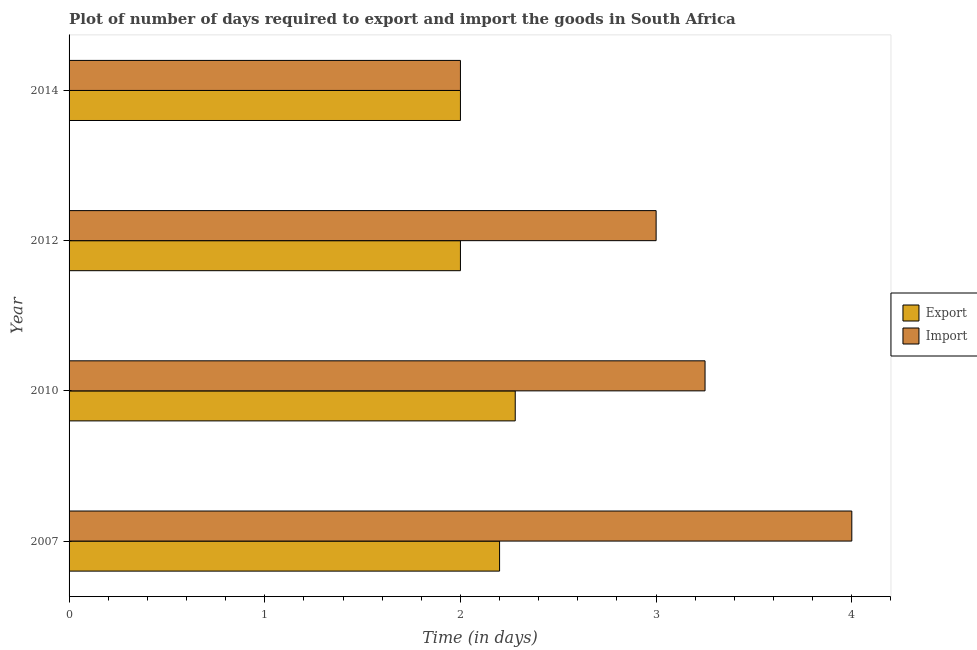How many different coloured bars are there?
Offer a very short reply. 2. Are the number of bars per tick equal to the number of legend labels?
Provide a succinct answer. Yes. Are the number of bars on each tick of the Y-axis equal?
Offer a very short reply. Yes. How many bars are there on the 3rd tick from the top?
Your answer should be compact. 2. How many bars are there on the 1st tick from the bottom?
Your response must be concise. 2. What is the label of the 2nd group of bars from the top?
Offer a very short reply. 2012. In which year was the time required to import maximum?
Ensure brevity in your answer.  2007. In which year was the time required to export minimum?
Make the answer very short. 2012. What is the total time required to export in the graph?
Ensure brevity in your answer.  8.48. What is the difference between the time required to export in 2010 and that in 2012?
Offer a very short reply. 0.28. What is the average time required to import per year?
Give a very brief answer. 3.06. In the year 2010, what is the difference between the time required to import and time required to export?
Your answer should be very brief. 0.97. What is the difference between the highest and the lowest time required to export?
Offer a terse response. 0.28. In how many years, is the time required to import greater than the average time required to import taken over all years?
Provide a short and direct response. 2. What does the 2nd bar from the top in 2010 represents?
Give a very brief answer. Export. What does the 1st bar from the bottom in 2010 represents?
Your answer should be compact. Export. Does the graph contain any zero values?
Ensure brevity in your answer.  No. Where does the legend appear in the graph?
Provide a succinct answer. Center right. How many legend labels are there?
Ensure brevity in your answer.  2. What is the title of the graph?
Offer a terse response. Plot of number of days required to export and import the goods in South Africa. What is the label or title of the X-axis?
Your response must be concise. Time (in days). What is the label or title of the Y-axis?
Your answer should be compact. Year. What is the Time (in days) of Export in 2007?
Your answer should be compact. 2.2. What is the Time (in days) in Import in 2007?
Keep it short and to the point. 4. What is the Time (in days) in Export in 2010?
Give a very brief answer. 2.28. What is the Time (in days) in Export in 2014?
Give a very brief answer. 2. What is the Time (in days) in Import in 2014?
Provide a succinct answer. 2. Across all years, what is the maximum Time (in days) of Export?
Offer a terse response. 2.28. What is the total Time (in days) in Export in the graph?
Your answer should be compact. 8.48. What is the total Time (in days) of Import in the graph?
Your answer should be compact. 12.25. What is the difference between the Time (in days) in Export in 2007 and that in 2010?
Give a very brief answer. -0.08. What is the difference between the Time (in days) of Export in 2007 and that in 2012?
Provide a succinct answer. 0.2. What is the difference between the Time (in days) in Import in 2007 and that in 2012?
Keep it short and to the point. 1. What is the difference between the Time (in days) in Export in 2007 and that in 2014?
Provide a short and direct response. 0.2. What is the difference between the Time (in days) of Export in 2010 and that in 2012?
Offer a very short reply. 0.28. What is the difference between the Time (in days) of Export in 2010 and that in 2014?
Your answer should be very brief. 0.28. What is the difference between the Time (in days) in Export in 2012 and that in 2014?
Your response must be concise. 0. What is the difference between the Time (in days) of Export in 2007 and the Time (in days) of Import in 2010?
Offer a terse response. -1.05. What is the difference between the Time (in days) in Export in 2007 and the Time (in days) in Import in 2014?
Offer a terse response. 0.2. What is the difference between the Time (in days) of Export in 2010 and the Time (in days) of Import in 2012?
Offer a terse response. -0.72. What is the difference between the Time (in days) of Export in 2010 and the Time (in days) of Import in 2014?
Ensure brevity in your answer.  0.28. What is the average Time (in days) of Export per year?
Keep it short and to the point. 2.12. What is the average Time (in days) in Import per year?
Offer a very short reply. 3.06. In the year 2007, what is the difference between the Time (in days) of Export and Time (in days) of Import?
Give a very brief answer. -1.8. In the year 2010, what is the difference between the Time (in days) in Export and Time (in days) in Import?
Give a very brief answer. -0.97. In the year 2014, what is the difference between the Time (in days) of Export and Time (in days) of Import?
Ensure brevity in your answer.  0. What is the ratio of the Time (in days) of Export in 2007 to that in 2010?
Provide a short and direct response. 0.96. What is the ratio of the Time (in days) in Import in 2007 to that in 2010?
Give a very brief answer. 1.23. What is the ratio of the Time (in days) of Export in 2007 to that in 2012?
Give a very brief answer. 1.1. What is the ratio of the Time (in days) of Import in 2007 to that in 2012?
Provide a succinct answer. 1.33. What is the ratio of the Time (in days) of Export in 2010 to that in 2012?
Give a very brief answer. 1.14. What is the ratio of the Time (in days) of Export in 2010 to that in 2014?
Provide a short and direct response. 1.14. What is the ratio of the Time (in days) in Import in 2010 to that in 2014?
Make the answer very short. 1.62. What is the difference between the highest and the lowest Time (in days) of Export?
Your answer should be compact. 0.28. 